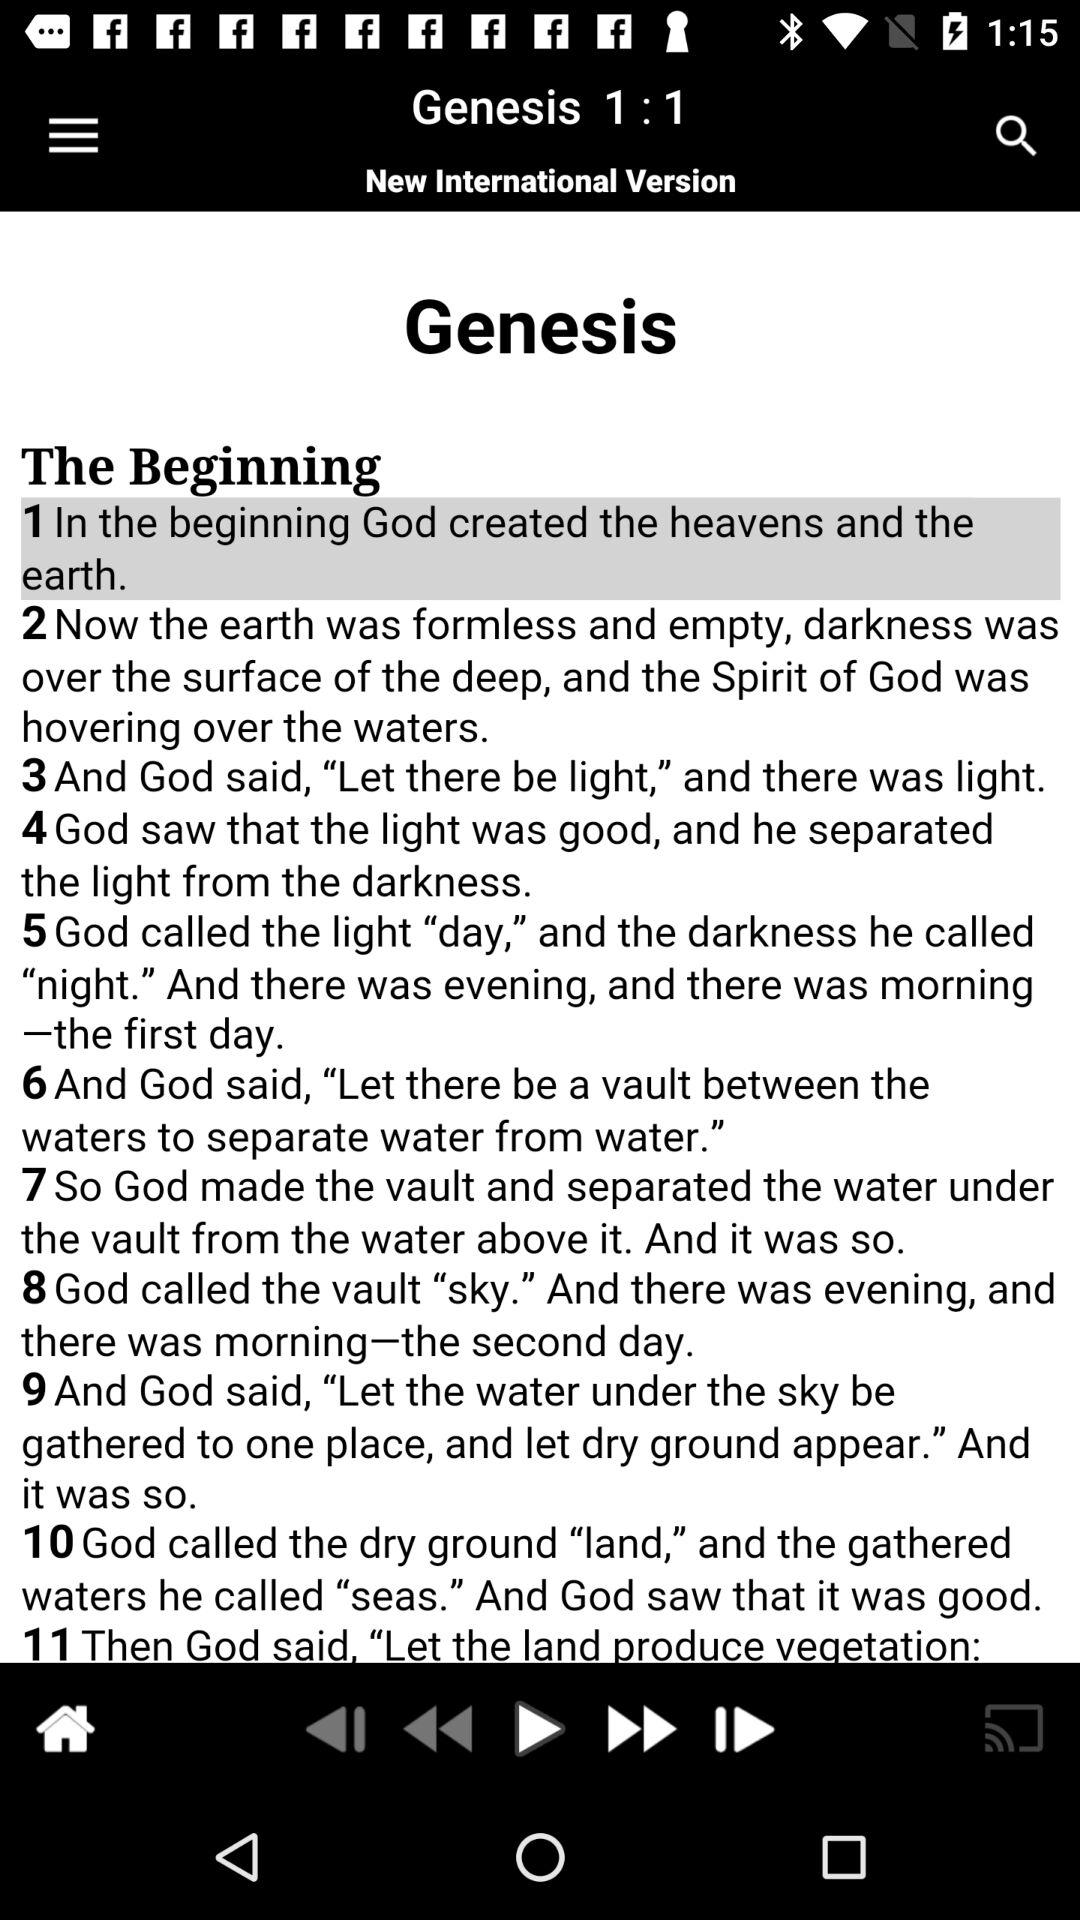How many verses are there in Genesis?
Answer the question using a single word or phrase. 11 